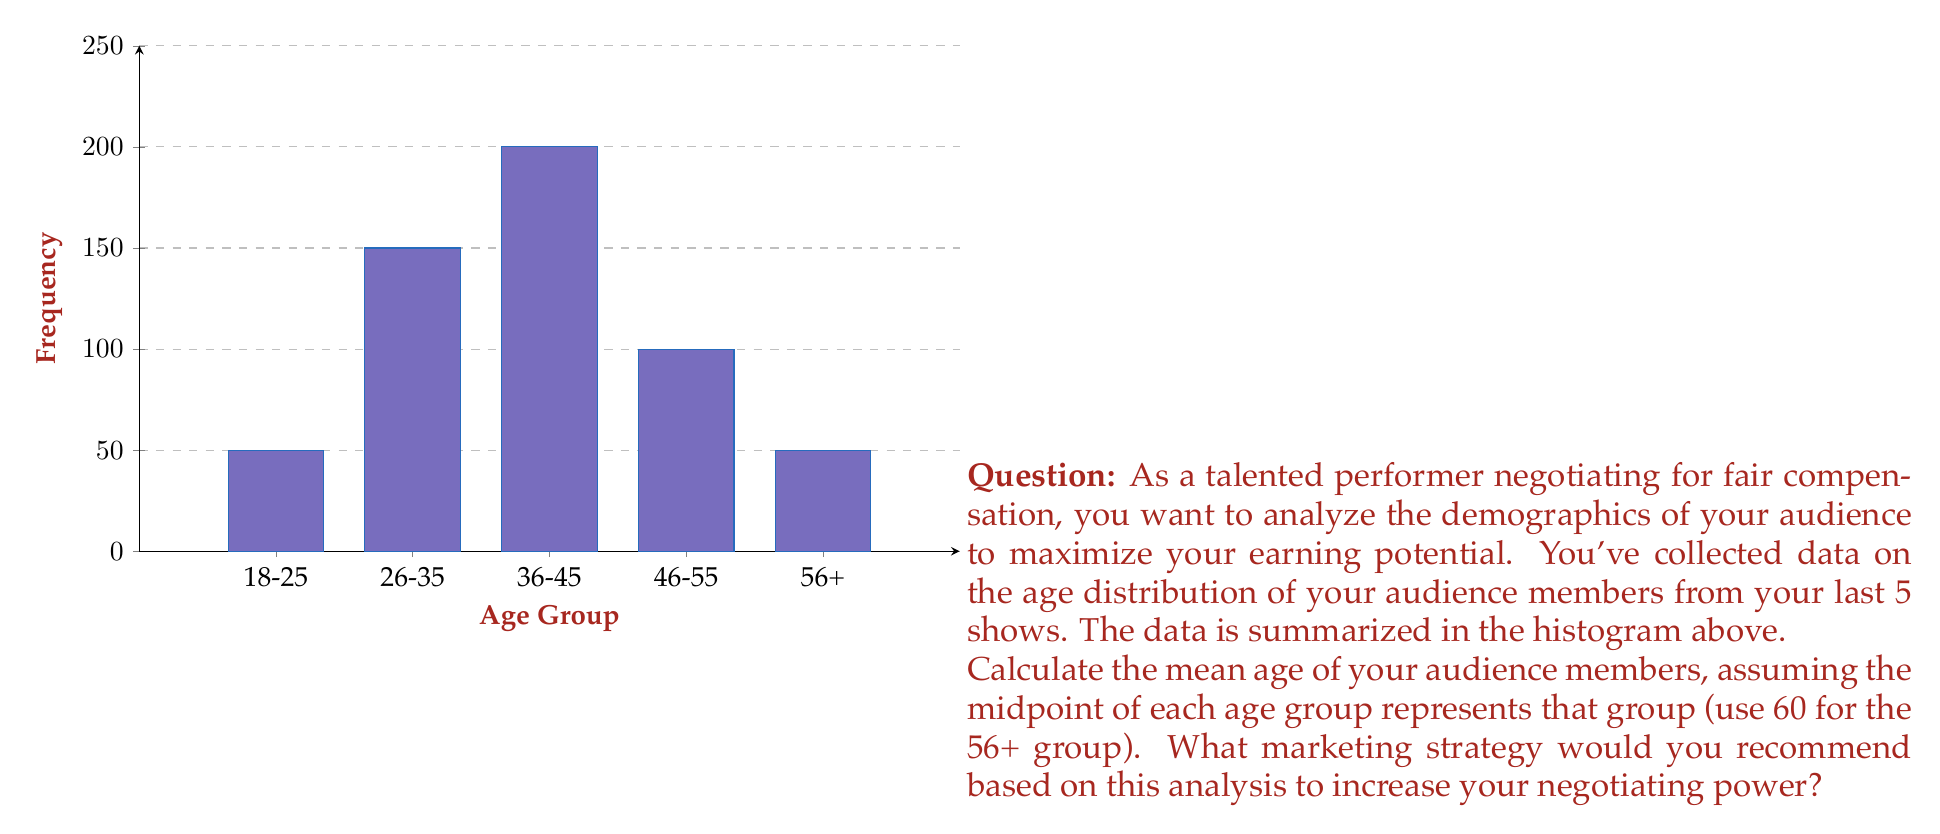Can you answer this question? To solve this problem, we need to follow these steps:

1) First, let's identify the midpoints of each age group:
   18-25: 21.5
   26-35: 30.5
   36-45: 40.5
   46-55: 50.5
   56+: 60 (as given)

2) Now, we need to multiply each midpoint by its frequency:
   21.5 * 50 = 1075
   30.5 * 150 = 4575
   40.5 * 200 = 8100
   50.5 * 100 = 5050
   60 * 50 = 3000

3) Sum up these products:
   1075 + 4575 + 8100 + 5050 + 3000 = 21800

4) Sum up the frequencies:
   50 + 150 + 200 + 100 + 50 = 550

5) Calculate the mean by dividing the sum of products by the sum of frequencies:
   $\text{Mean} = \frac{21800}{550} = 39.64$

6) The mean age of the audience is approximately 39.64 years.

Based on this analysis, the performer could recommend a marketing strategy targeting the 36-45 age group, as this is the most frequent group and close to the mean age. This could involve tailoring content to appeal to this demographic, advertising in media popular with this age group, or creating merchandise that appeals to them. 

By demonstrating a clear understanding of the audience demographics, the performer can negotiate for higher compensation, arguing that they can attract and retain a valuable audience segment. They could also use this data to propose targeted marketing campaigns or sponsorship deals, further increasing their value and negotiating power.
Answer: Mean age: 39.64 years. Recommend targeting 36-45 age group in marketing to increase negotiating power. 